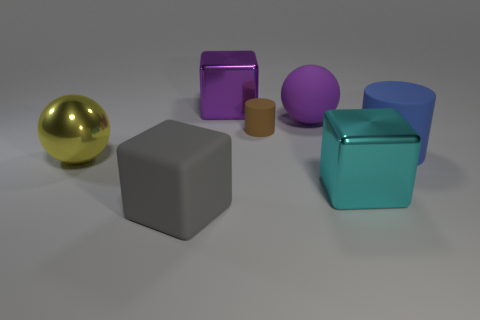How many matte objects have the same shape as the yellow shiny object?
Provide a short and direct response. 1. What number of purple objects are big matte objects or big matte cylinders?
Provide a short and direct response. 1. What size is the cylinder that is on the left side of the big ball that is on the right side of the gray rubber cube?
Your answer should be compact. Small. There is a big blue object that is the same shape as the tiny brown matte thing; what is its material?
Provide a short and direct response. Rubber. How many rubber blocks are the same size as the purple shiny block?
Keep it short and to the point. 1. Is the size of the purple matte sphere the same as the purple block?
Provide a succinct answer. Yes. What size is the cube that is to the left of the purple rubber object and behind the gray object?
Give a very brief answer. Large. Is the number of cylinders on the left side of the large blue cylinder greater than the number of yellow metal balls that are on the right side of the big purple metallic thing?
Your response must be concise. Yes. What color is the metal object that is the same shape as the purple matte thing?
Make the answer very short. Yellow. There is a block behind the big blue thing; is its color the same as the big matte ball?
Your response must be concise. Yes. 